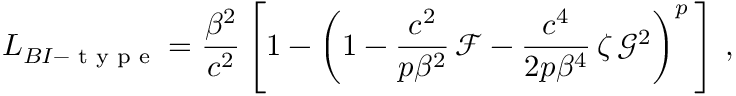Convert formula to latex. <formula><loc_0><loc_0><loc_500><loc_500>L _ { B I - t y p e } = \frac { \beta ^ { 2 } } { c ^ { 2 } } \left [ 1 - \left ( 1 - \frac { c ^ { 2 } } { p \beta ^ { 2 } } \, \mathcal { F } - \frac { c ^ { 4 } } { 2 p \beta ^ { 4 } } \, \zeta \, \mathcal { G } ^ { 2 } \right ) ^ { p } \, \right ] \, ,</formula> 